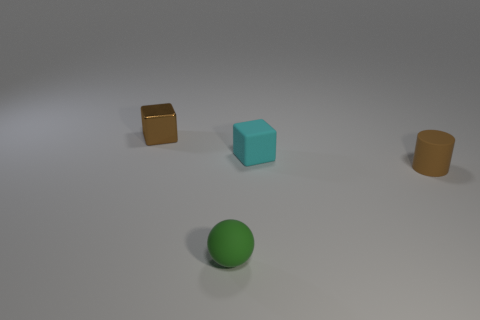What material is the cyan object?
Make the answer very short. Rubber. What is the size of the brown object in front of the tiny brown thing that is left of the object that is on the right side of the cyan cube?
Make the answer very short. Small. There is a tiny block that is the same color as the small rubber cylinder; what material is it?
Offer a terse response. Metal. What number of metallic objects are either big green cubes or tiny brown cylinders?
Provide a succinct answer. 0. The brown metal cube has what size?
Keep it short and to the point. Small. How many objects are either cyan metal spheres or small brown things that are on the right side of the brown block?
Provide a succinct answer. 1. What number of other objects are there of the same color as the small matte sphere?
Offer a terse response. 0. There is a cylinder; is its size the same as the matte object that is behind the rubber cylinder?
Your response must be concise. Yes. Does the thing that is left of the ball have the same size as the green matte object?
Offer a terse response. Yes. How many other things are made of the same material as the tiny green thing?
Your answer should be very brief. 2. 